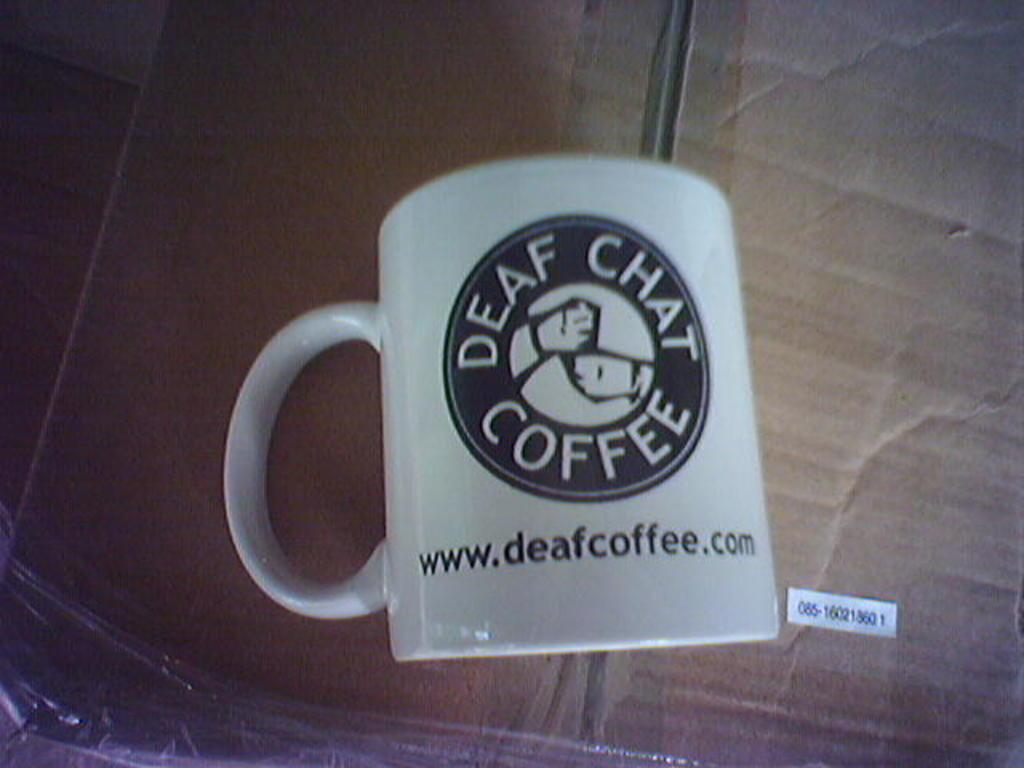<image>
Relay a brief, clear account of the picture shown. A coffee mug that says Deaf Chat Coffee. 